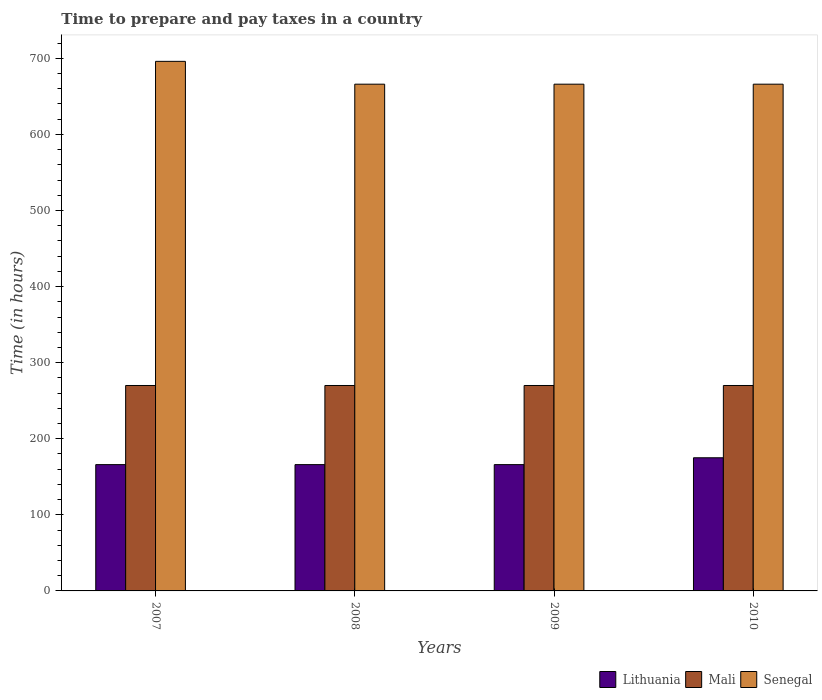How many different coloured bars are there?
Keep it short and to the point. 3. How many groups of bars are there?
Keep it short and to the point. 4. Are the number of bars on each tick of the X-axis equal?
Your response must be concise. Yes. How many bars are there on the 3rd tick from the left?
Ensure brevity in your answer.  3. How many bars are there on the 3rd tick from the right?
Ensure brevity in your answer.  3. What is the label of the 3rd group of bars from the left?
Your answer should be very brief. 2009. What is the number of hours required to prepare and pay taxes in Mali in 2007?
Keep it short and to the point. 270. Across all years, what is the maximum number of hours required to prepare and pay taxes in Senegal?
Your response must be concise. 696. Across all years, what is the minimum number of hours required to prepare and pay taxes in Mali?
Keep it short and to the point. 270. In which year was the number of hours required to prepare and pay taxes in Senegal maximum?
Give a very brief answer. 2007. In which year was the number of hours required to prepare and pay taxes in Lithuania minimum?
Keep it short and to the point. 2007. What is the total number of hours required to prepare and pay taxes in Senegal in the graph?
Make the answer very short. 2694. What is the difference between the number of hours required to prepare and pay taxes in Mali in 2007 and that in 2010?
Offer a terse response. 0. What is the difference between the number of hours required to prepare and pay taxes in Senegal in 2007 and the number of hours required to prepare and pay taxes in Lithuania in 2010?
Offer a very short reply. 521. What is the average number of hours required to prepare and pay taxes in Senegal per year?
Provide a short and direct response. 673.5. In the year 2010, what is the difference between the number of hours required to prepare and pay taxes in Lithuania and number of hours required to prepare and pay taxes in Senegal?
Ensure brevity in your answer.  -491. What is the ratio of the number of hours required to prepare and pay taxes in Lithuania in 2008 to that in 2010?
Provide a short and direct response. 0.95. Is the number of hours required to prepare and pay taxes in Mali in 2008 less than that in 2010?
Give a very brief answer. No. What is the difference between the highest and the second highest number of hours required to prepare and pay taxes in Lithuania?
Your answer should be compact. 9. What is the difference between the highest and the lowest number of hours required to prepare and pay taxes in Lithuania?
Offer a very short reply. 9. In how many years, is the number of hours required to prepare and pay taxes in Senegal greater than the average number of hours required to prepare and pay taxes in Senegal taken over all years?
Provide a short and direct response. 1. What does the 1st bar from the left in 2009 represents?
Offer a terse response. Lithuania. What does the 2nd bar from the right in 2008 represents?
Provide a short and direct response. Mali. How many bars are there?
Provide a short and direct response. 12. What is the difference between two consecutive major ticks on the Y-axis?
Offer a terse response. 100. Does the graph contain any zero values?
Make the answer very short. No. How are the legend labels stacked?
Ensure brevity in your answer.  Horizontal. What is the title of the graph?
Keep it short and to the point. Time to prepare and pay taxes in a country. Does "Central Europe" appear as one of the legend labels in the graph?
Ensure brevity in your answer.  No. What is the label or title of the X-axis?
Make the answer very short. Years. What is the label or title of the Y-axis?
Your response must be concise. Time (in hours). What is the Time (in hours) of Lithuania in 2007?
Make the answer very short. 166. What is the Time (in hours) in Mali in 2007?
Your answer should be very brief. 270. What is the Time (in hours) of Senegal in 2007?
Offer a very short reply. 696. What is the Time (in hours) of Lithuania in 2008?
Provide a succinct answer. 166. What is the Time (in hours) in Mali in 2008?
Provide a succinct answer. 270. What is the Time (in hours) in Senegal in 2008?
Offer a terse response. 666. What is the Time (in hours) in Lithuania in 2009?
Offer a terse response. 166. What is the Time (in hours) in Mali in 2009?
Keep it short and to the point. 270. What is the Time (in hours) of Senegal in 2009?
Your response must be concise. 666. What is the Time (in hours) of Lithuania in 2010?
Keep it short and to the point. 175. What is the Time (in hours) in Mali in 2010?
Your answer should be compact. 270. What is the Time (in hours) in Senegal in 2010?
Make the answer very short. 666. Across all years, what is the maximum Time (in hours) in Lithuania?
Keep it short and to the point. 175. Across all years, what is the maximum Time (in hours) in Mali?
Your response must be concise. 270. Across all years, what is the maximum Time (in hours) in Senegal?
Offer a terse response. 696. Across all years, what is the minimum Time (in hours) in Lithuania?
Your answer should be very brief. 166. Across all years, what is the minimum Time (in hours) of Mali?
Provide a succinct answer. 270. Across all years, what is the minimum Time (in hours) in Senegal?
Your answer should be compact. 666. What is the total Time (in hours) in Lithuania in the graph?
Give a very brief answer. 673. What is the total Time (in hours) in Mali in the graph?
Ensure brevity in your answer.  1080. What is the total Time (in hours) of Senegal in the graph?
Make the answer very short. 2694. What is the difference between the Time (in hours) in Mali in 2007 and that in 2008?
Give a very brief answer. 0. What is the difference between the Time (in hours) in Senegal in 2007 and that in 2008?
Your response must be concise. 30. What is the difference between the Time (in hours) in Lithuania in 2007 and that in 2009?
Offer a very short reply. 0. What is the difference between the Time (in hours) in Senegal in 2007 and that in 2010?
Your response must be concise. 30. What is the difference between the Time (in hours) of Senegal in 2008 and that in 2009?
Provide a succinct answer. 0. What is the difference between the Time (in hours) in Mali in 2008 and that in 2010?
Your response must be concise. 0. What is the difference between the Time (in hours) of Senegal in 2008 and that in 2010?
Provide a short and direct response. 0. What is the difference between the Time (in hours) in Lithuania in 2009 and that in 2010?
Your answer should be compact. -9. What is the difference between the Time (in hours) in Mali in 2009 and that in 2010?
Give a very brief answer. 0. What is the difference between the Time (in hours) of Senegal in 2009 and that in 2010?
Keep it short and to the point. 0. What is the difference between the Time (in hours) of Lithuania in 2007 and the Time (in hours) of Mali in 2008?
Keep it short and to the point. -104. What is the difference between the Time (in hours) of Lithuania in 2007 and the Time (in hours) of Senegal in 2008?
Give a very brief answer. -500. What is the difference between the Time (in hours) in Mali in 2007 and the Time (in hours) in Senegal in 2008?
Offer a very short reply. -396. What is the difference between the Time (in hours) in Lithuania in 2007 and the Time (in hours) in Mali in 2009?
Provide a short and direct response. -104. What is the difference between the Time (in hours) in Lithuania in 2007 and the Time (in hours) in Senegal in 2009?
Provide a short and direct response. -500. What is the difference between the Time (in hours) in Mali in 2007 and the Time (in hours) in Senegal in 2009?
Make the answer very short. -396. What is the difference between the Time (in hours) in Lithuania in 2007 and the Time (in hours) in Mali in 2010?
Your answer should be very brief. -104. What is the difference between the Time (in hours) in Lithuania in 2007 and the Time (in hours) in Senegal in 2010?
Offer a very short reply. -500. What is the difference between the Time (in hours) in Mali in 2007 and the Time (in hours) in Senegal in 2010?
Keep it short and to the point. -396. What is the difference between the Time (in hours) in Lithuania in 2008 and the Time (in hours) in Mali in 2009?
Keep it short and to the point. -104. What is the difference between the Time (in hours) in Lithuania in 2008 and the Time (in hours) in Senegal in 2009?
Give a very brief answer. -500. What is the difference between the Time (in hours) in Mali in 2008 and the Time (in hours) in Senegal in 2009?
Make the answer very short. -396. What is the difference between the Time (in hours) in Lithuania in 2008 and the Time (in hours) in Mali in 2010?
Provide a succinct answer. -104. What is the difference between the Time (in hours) in Lithuania in 2008 and the Time (in hours) in Senegal in 2010?
Provide a short and direct response. -500. What is the difference between the Time (in hours) in Mali in 2008 and the Time (in hours) in Senegal in 2010?
Your answer should be very brief. -396. What is the difference between the Time (in hours) of Lithuania in 2009 and the Time (in hours) of Mali in 2010?
Ensure brevity in your answer.  -104. What is the difference between the Time (in hours) in Lithuania in 2009 and the Time (in hours) in Senegal in 2010?
Make the answer very short. -500. What is the difference between the Time (in hours) in Mali in 2009 and the Time (in hours) in Senegal in 2010?
Give a very brief answer. -396. What is the average Time (in hours) of Lithuania per year?
Offer a terse response. 168.25. What is the average Time (in hours) in Mali per year?
Your answer should be very brief. 270. What is the average Time (in hours) of Senegal per year?
Offer a terse response. 673.5. In the year 2007, what is the difference between the Time (in hours) in Lithuania and Time (in hours) in Mali?
Your response must be concise. -104. In the year 2007, what is the difference between the Time (in hours) of Lithuania and Time (in hours) of Senegal?
Offer a terse response. -530. In the year 2007, what is the difference between the Time (in hours) in Mali and Time (in hours) in Senegal?
Your answer should be very brief. -426. In the year 2008, what is the difference between the Time (in hours) in Lithuania and Time (in hours) in Mali?
Ensure brevity in your answer.  -104. In the year 2008, what is the difference between the Time (in hours) in Lithuania and Time (in hours) in Senegal?
Your answer should be very brief. -500. In the year 2008, what is the difference between the Time (in hours) of Mali and Time (in hours) of Senegal?
Your response must be concise. -396. In the year 2009, what is the difference between the Time (in hours) of Lithuania and Time (in hours) of Mali?
Your answer should be very brief. -104. In the year 2009, what is the difference between the Time (in hours) of Lithuania and Time (in hours) of Senegal?
Offer a very short reply. -500. In the year 2009, what is the difference between the Time (in hours) in Mali and Time (in hours) in Senegal?
Offer a terse response. -396. In the year 2010, what is the difference between the Time (in hours) in Lithuania and Time (in hours) in Mali?
Your answer should be compact. -95. In the year 2010, what is the difference between the Time (in hours) in Lithuania and Time (in hours) in Senegal?
Provide a succinct answer. -491. In the year 2010, what is the difference between the Time (in hours) of Mali and Time (in hours) of Senegal?
Provide a succinct answer. -396. What is the ratio of the Time (in hours) in Senegal in 2007 to that in 2008?
Your response must be concise. 1.04. What is the ratio of the Time (in hours) of Senegal in 2007 to that in 2009?
Provide a short and direct response. 1.04. What is the ratio of the Time (in hours) of Lithuania in 2007 to that in 2010?
Your answer should be compact. 0.95. What is the ratio of the Time (in hours) of Senegal in 2007 to that in 2010?
Your response must be concise. 1.04. What is the ratio of the Time (in hours) in Lithuania in 2008 to that in 2009?
Offer a terse response. 1. What is the ratio of the Time (in hours) in Lithuania in 2008 to that in 2010?
Keep it short and to the point. 0.95. What is the ratio of the Time (in hours) in Mali in 2008 to that in 2010?
Your answer should be compact. 1. What is the ratio of the Time (in hours) of Senegal in 2008 to that in 2010?
Your answer should be compact. 1. What is the ratio of the Time (in hours) of Lithuania in 2009 to that in 2010?
Offer a terse response. 0.95. What is the difference between the highest and the second highest Time (in hours) of Lithuania?
Provide a short and direct response. 9. What is the difference between the highest and the second highest Time (in hours) of Mali?
Provide a succinct answer. 0. What is the difference between the highest and the second highest Time (in hours) in Senegal?
Give a very brief answer. 30. 